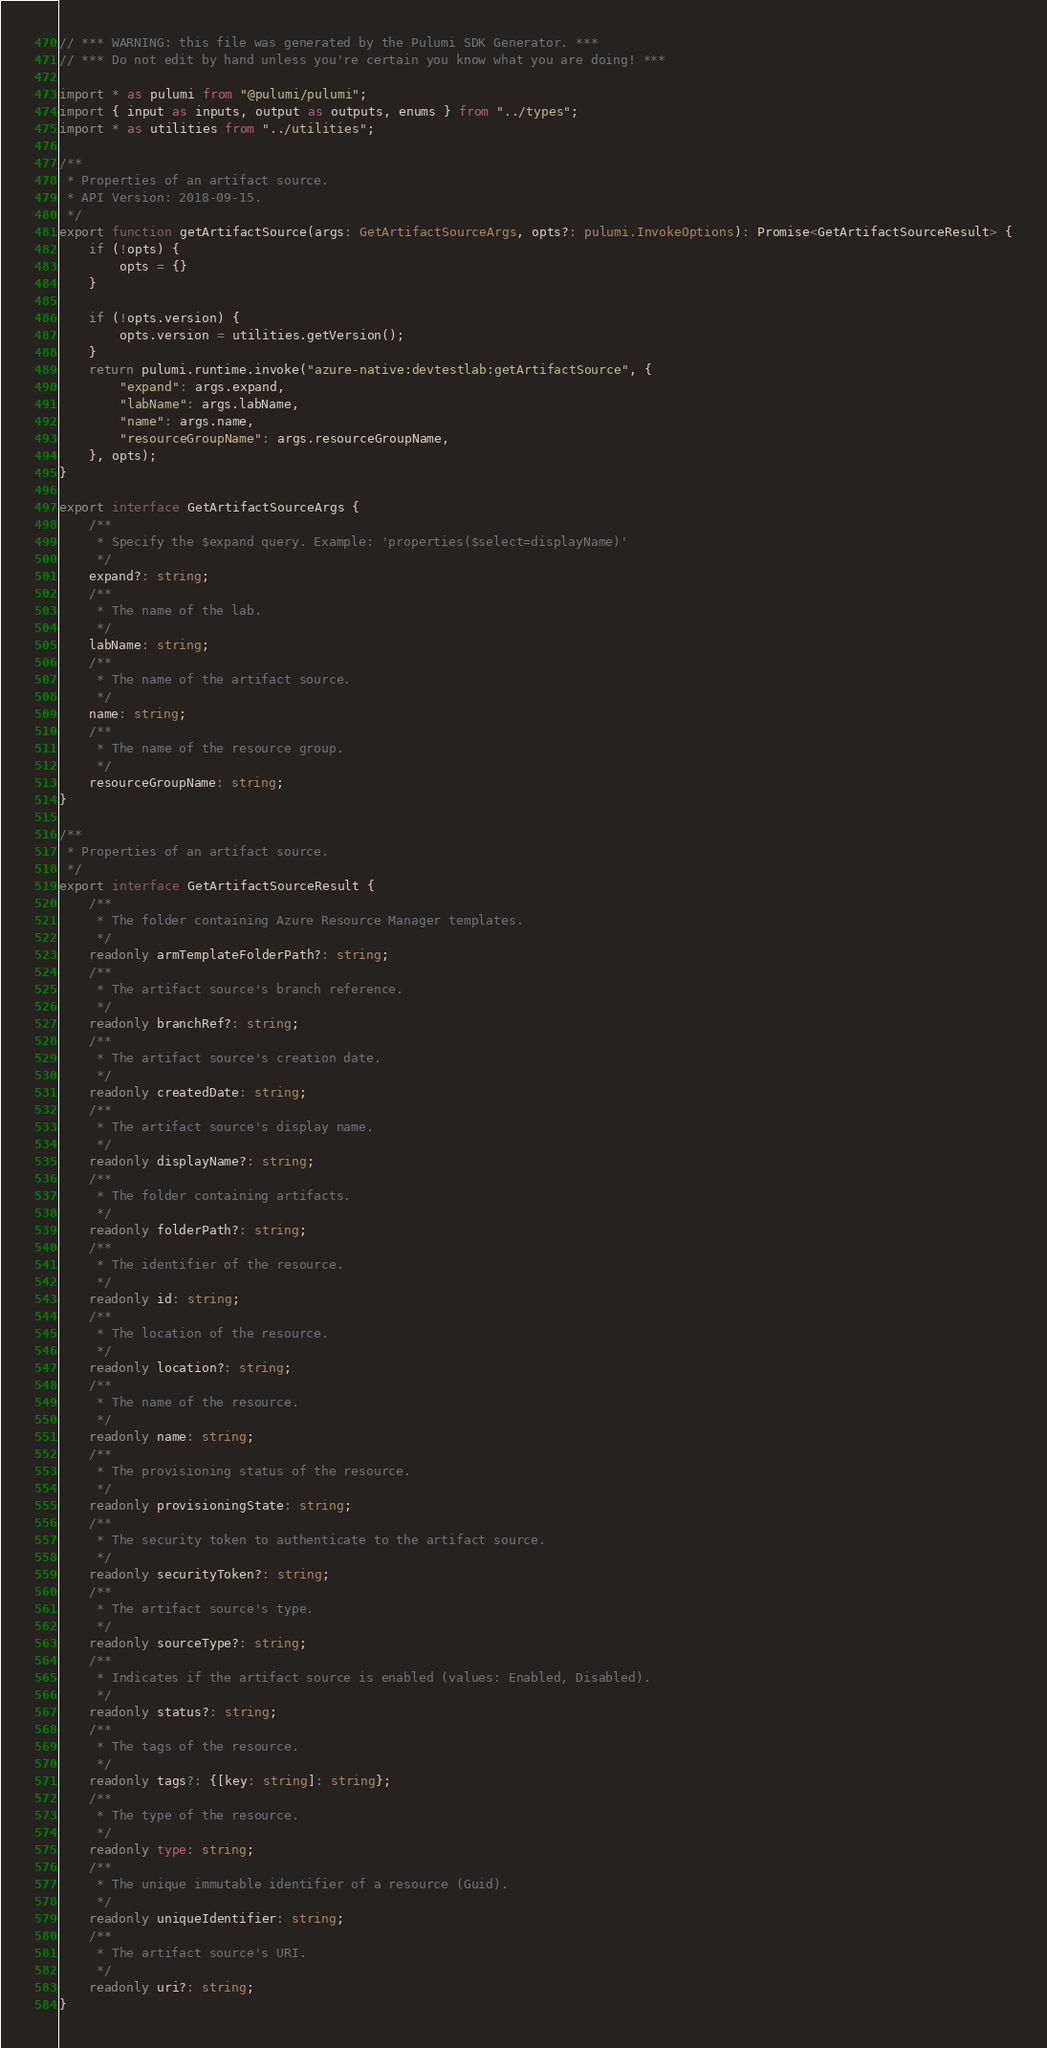Convert code to text. <code><loc_0><loc_0><loc_500><loc_500><_TypeScript_>// *** WARNING: this file was generated by the Pulumi SDK Generator. ***
// *** Do not edit by hand unless you're certain you know what you are doing! ***

import * as pulumi from "@pulumi/pulumi";
import { input as inputs, output as outputs, enums } from "../types";
import * as utilities from "../utilities";

/**
 * Properties of an artifact source.
 * API Version: 2018-09-15.
 */
export function getArtifactSource(args: GetArtifactSourceArgs, opts?: pulumi.InvokeOptions): Promise<GetArtifactSourceResult> {
    if (!opts) {
        opts = {}
    }

    if (!opts.version) {
        opts.version = utilities.getVersion();
    }
    return pulumi.runtime.invoke("azure-native:devtestlab:getArtifactSource", {
        "expand": args.expand,
        "labName": args.labName,
        "name": args.name,
        "resourceGroupName": args.resourceGroupName,
    }, opts);
}

export interface GetArtifactSourceArgs {
    /**
     * Specify the $expand query. Example: 'properties($select=displayName)'
     */
    expand?: string;
    /**
     * The name of the lab.
     */
    labName: string;
    /**
     * The name of the artifact source.
     */
    name: string;
    /**
     * The name of the resource group.
     */
    resourceGroupName: string;
}

/**
 * Properties of an artifact source.
 */
export interface GetArtifactSourceResult {
    /**
     * The folder containing Azure Resource Manager templates.
     */
    readonly armTemplateFolderPath?: string;
    /**
     * The artifact source's branch reference.
     */
    readonly branchRef?: string;
    /**
     * The artifact source's creation date.
     */
    readonly createdDate: string;
    /**
     * The artifact source's display name.
     */
    readonly displayName?: string;
    /**
     * The folder containing artifacts.
     */
    readonly folderPath?: string;
    /**
     * The identifier of the resource.
     */
    readonly id: string;
    /**
     * The location of the resource.
     */
    readonly location?: string;
    /**
     * The name of the resource.
     */
    readonly name: string;
    /**
     * The provisioning status of the resource.
     */
    readonly provisioningState: string;
    /**
     * The security token to authenticate to the artifact source.
     */
    readonly securityToken?: string;
    /**
     * The artifact source's type.
     */
    readonly sourceType?: string;
    /**
     * Indicates if the artifact source is enabled (values: Enabled, Disabled).
     */
    readonly status?: string;
    /**
     * The tags of the resource.
     */
    readonly tags?: {[key: string]: string};
    /**
     * The type of the resource.
     */
    readonly type: string;
    /**
     * The unique immutable identifier of a resource (Guid).
     */
    readonly uniqueIdentifier: string;
    /**
     * The artifact source's URI.
     */
    readonly uri?: string;
}
</code> 